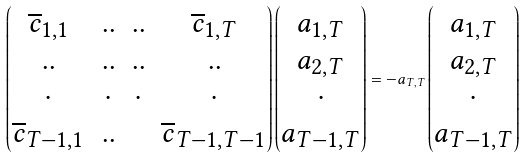<formula> <loc_0><loc_0><loc_500><loc_500>\begin{pmatrix} \overline { c } _ { 1 , 1 } & . . & . . & \overline { c } _ { 1 , T } \\ . . & . . & . . & . . \\ \cdot & \cdot & \cdot & \cdot \\ \overline { c } _ { T - 1 , 1 } & . . & & \overline { c } _ { T - 1 , T - 1 } \end{pmatrix} \begin{pmatrix} a _ { 1 , T } \\ a _ { 2 , T } \\ \cdot \\ a _ { T - 1 , T } \end{pmatrix} = - a _ { T , T } \begin{pmatrix} a _ { 1 , T } \\ a _ { 2 , T } \\ \cdot \\ a _ { T - 1 , T } \end{pmatrix}</formula> 